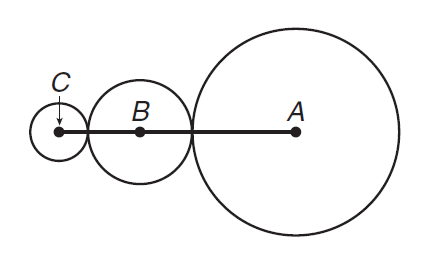Answer the mathemtical geometry problem and directly provide the correct option letter.
Question: G R I D I N In the figure, the radius of circle A is twice the radius of circle B and four times the radius of circle C. If the sum of the circumferences of the three circles is 42 \pi, find the measure of A C.
Choices: A: 16 B: 18 C: 27 D: 42 C 